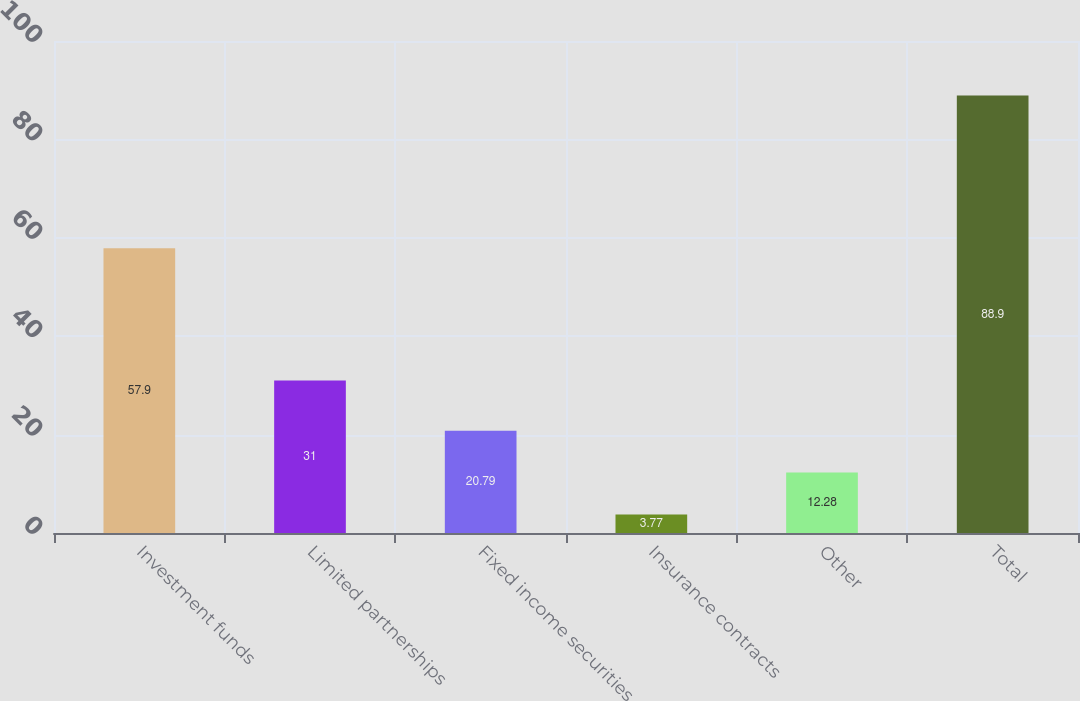Convert chart to OTSL. <chart><loc_0><loc_0><loc_500><loc_500><bar_chart><fcel>Investment funds<fcel>Limited partnerships<fcel>Fixed income securities<fcel>Insurance contracts<fcel>Other<fcel>Total<nl><fcel>57.9<fcel>31<fcel>20.79<fcel>3.77<fcel>12.28<fcel>88.9<nl></chart> 